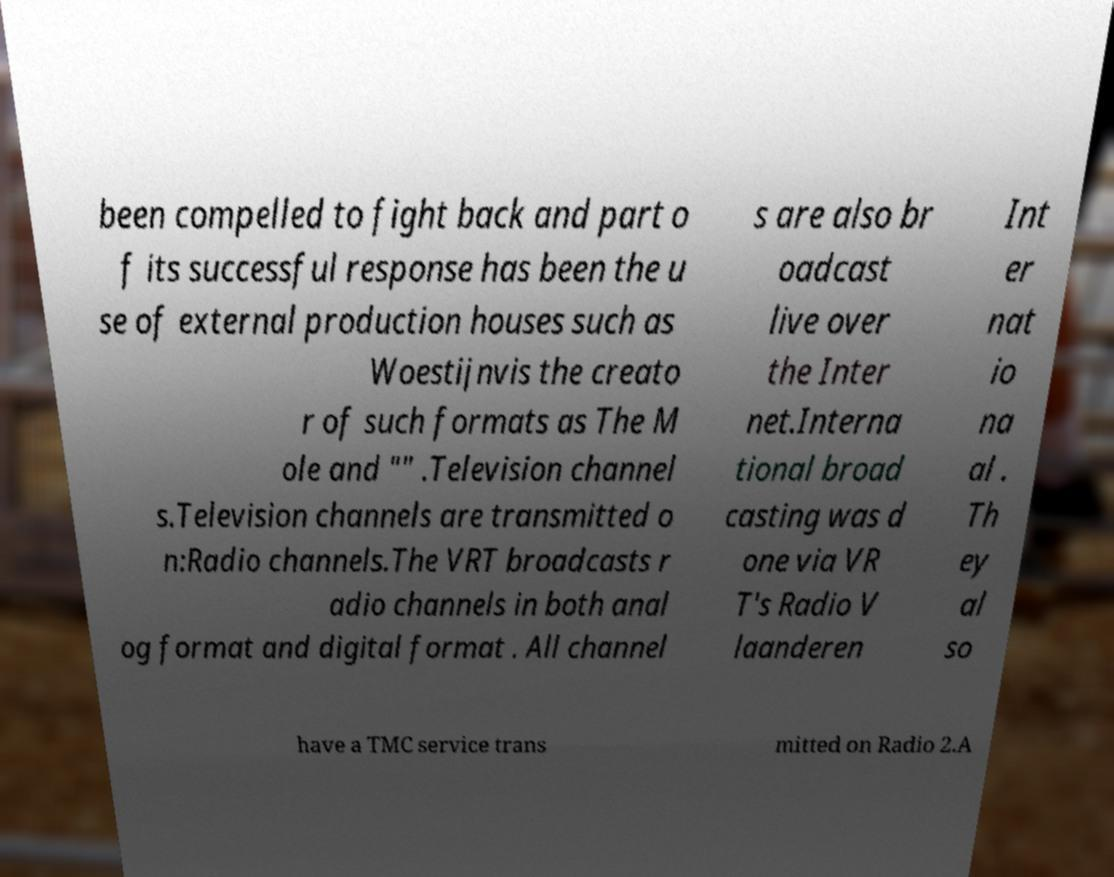Can you accurately transcribe the text from the provided image for me? been compelled to fight back and part o f its successful response has been the u se of external production houses such as Woestijnvis the creato r of such formats as The M ole and "" .Television channel s.Television channels are transmitted o n:Radio channels.The VRT broadcasts r adio channels in both anal og format and digital format . All channel s are also br oadcast live over the Inter net.Interna tional broad casting was d one via VR T's Radio V laanderen Int er nat io na al . Th ey al so have a TMC service trans mitted on Radio 2.A 